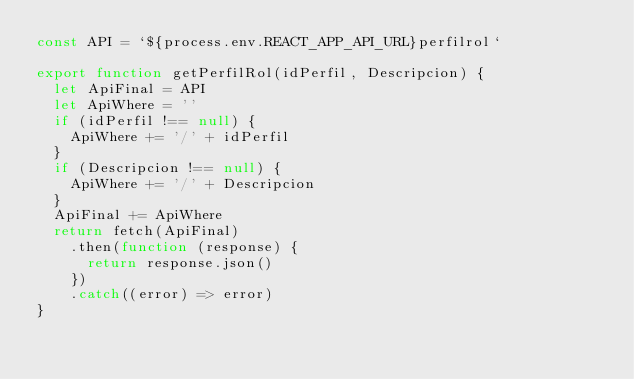Convert code to text. <code><loc_0><loc_0><loc_500><loc_500><_JavaScript_>const API = `${process.env.REACT_APP_API_URL}perfilrol`

export function getPerfilRol(idPerfil, Descripcion) {
  let ApiFinal = API
  let ApiWhere = ''
  if (idPerfil !== null) {
    ApiWhere += '/' + idPerfil
  }
  if (Descripcion !== null) {
    ApiWhere += '/' + Descripcion
  }
  ApiFinal += ApiWhere
  return fetch(ApiFinal)
    .then(function (response) {
      return response.json()
    })
    .catch((error) => error)
}
</code> 